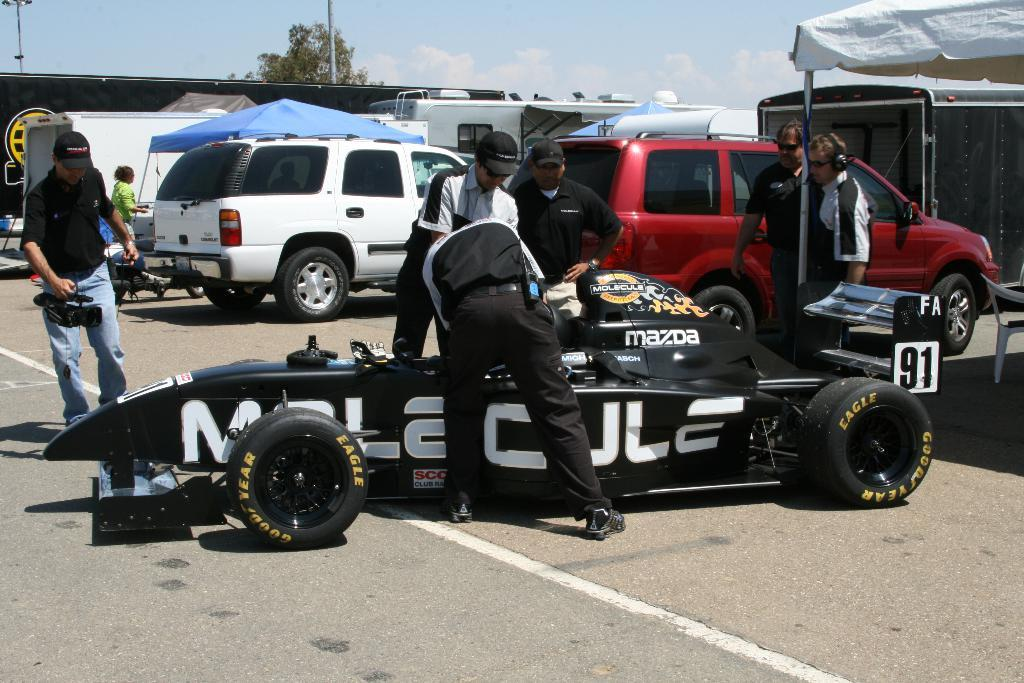What types of objects are present in the image? There are vehicles and a group of people in the image. What else can be seen in the image besides the vehicles and people? There are poles and a tree in the image. What is visible in the background of the image? The sky is visible in the background of the image. How many thumbs can be seen performing magic in the image? There are no thumbs or magic tricks present in the image. What shape is the circle that the tree is growing in the image? There is no circle mentioned or depicted in the image; the tree is growing naturally. 